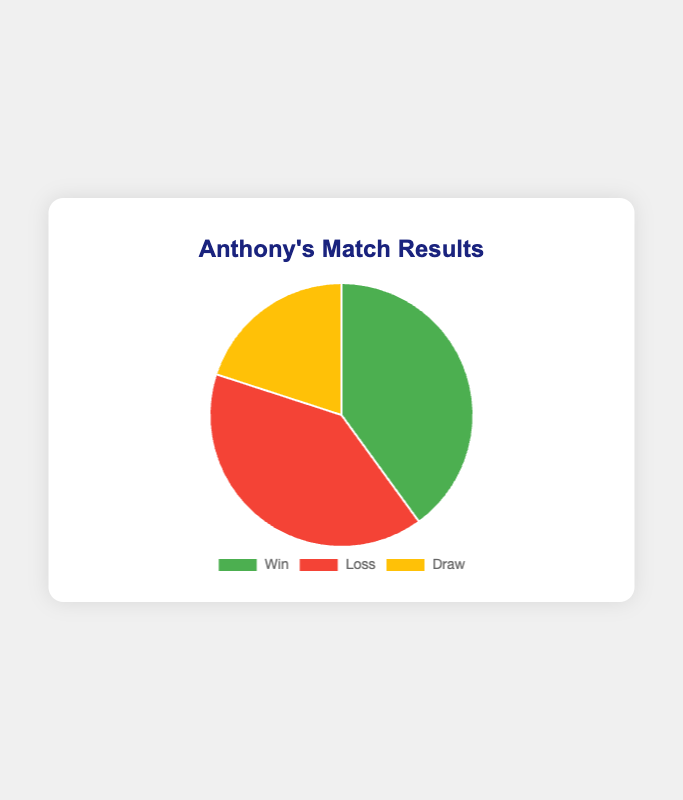Which match result has the highest proportion of matches? The pie chart shows three segments representing wins, losses, and draws. By observing the size of the segments, wins and losses occupy the largest portion, each indicating a higher proportion than draws.
Answer: Win and Loss How many matches ended in a draw? According to the labels and data on the pie chart, there is one match that ended in a draw.
Answer: 1 What is the combined proportion of wins and draws? Wins and draws are represented by different segments on the pie chart. Adding the number of wins (2) and draws (1) gives a total of 3 matches out of 5. So, the combined proportion is 3/5 or 60%.
Answer: 60% Which result had a greater proportion, losses or draws? By comparing the segments visually, the segment for losses is larger than that for draws. This indicates a greater proportion for losses.
Answer: Losses If the match results are represented in a pie chart, what color represents the wins? By observing the visual attributes of the pie chart, the wins are represented by the green segment.
Answer: Green How does the proportion of wins compare to losses? The pie chart shows two segments for wins and losses. Each segment has the same size, indicating that the proportion of wins equals the proportion of losses.
Answer: Equal What visual feature indicates the number of wins? The green segment of the pie chart represents wins. It occupies a proportional area on the chart, and the specific number can be read from the legend or tooltip describing the chart data.
Answer: Green segment What is the proportion of matches that did not result in a win? Matches that did not result in a win include losses and draws. Losses are 2, and draws are 1, totaling 3 matches out of 5. The proportion is 3/5 or 60%.
Answer: 60% Which match result has the smallest proportion? Observing the pie chart, the segment for draws is the smallest, indicating that draws have the smallest proportion.
Answer: Draw What proportion of matches were either wins or losses? Wins and losses each have 2 matches. Combined, they make 2 + 2 = 4 matches out of 5. The proportion is 4/5 or 80%.
Answer: 80% 